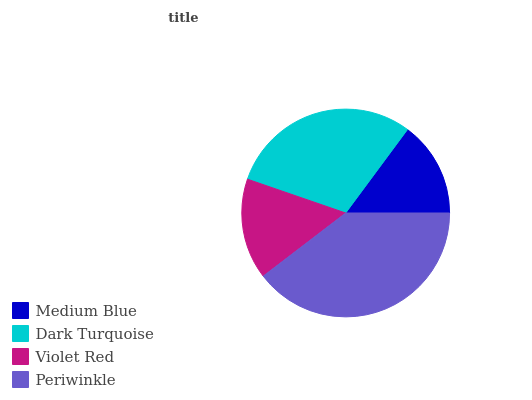Is Medium Blue the minimum?
Answer yes or no. Yes. Is Periwinkle the maximum?
Answer yes or no. Yes. Is Dark Turquoise the minimum?
Answer yes or no. No. Is Dark Turquoise the maximum?
Answer yes or no. No. Is Dark Turquoise greater than Medium Blue?
Answer yes or no. Yes. Is Medium Blue less than Dark Turquoise?
Answer yes or no. Yes. Is Medium Blue greater than Dark Turquoise?
Answer yes or no. No. Is Dark Turquoise less than Medium Blue?
Answer yes or no. No. Is Dark Turquoise the high median?
Answer yes or no. Yes. Is Violet Red the low median?
Answer yes or no. Yes. Is Periwinkle the high median?
Answer yes or no. No. Is Dark Turquoise the low median?
Answer yes or no. No. 